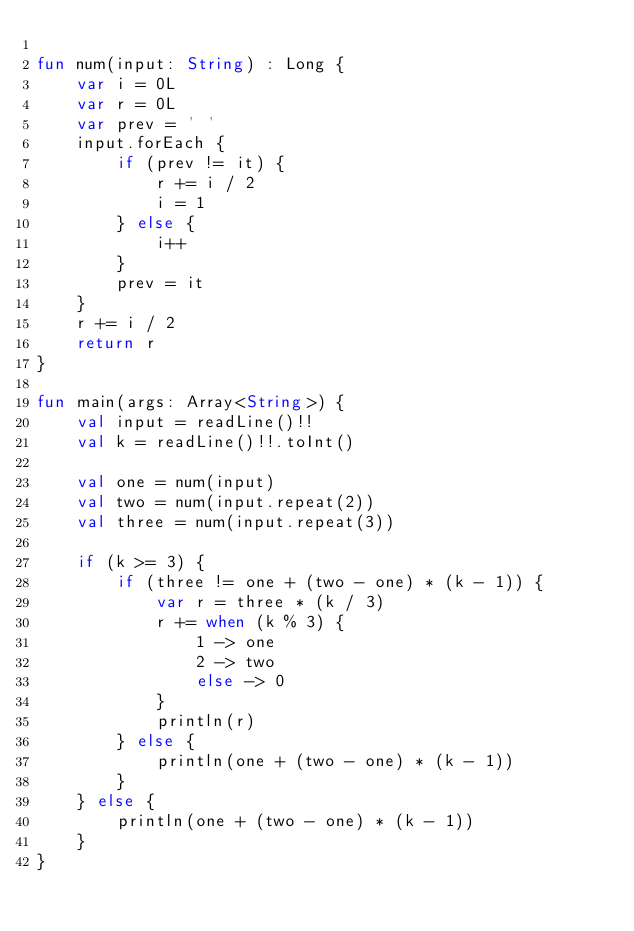<code> <loc_0><loc_0><loc_500><loc_500><_Kotlin_>
fun num(input: String) : Long {
    var i = 0L
    var r = 0L
    var prev = ' '
    input.forEach {
        if (prev != it) {
            r += i / 2
            i = 1
        } else {
            i++
        }
        prev = it
    }
    r += i / 2
    return r
}

fun main(args: Array<String>) {
    val input = readLine()!!
    val k = readLine()!!.toInt()

    val one = num(input)
    val two = num(input.repeat(2))
    val three = num(input.repeat(3))

    if (k >= 3) {
        if (three != one + (two - one) * (k - 1)) {
            var r = three * (k / 3)
            r += when (k % 3) {
                1 -> one
                2 -> two
                else -> 0
            }
            println(r)
        } else {
            println(one + (two - one) * (k - 1))
        }
    } else {
        println(one + (two - one) * (k - 1))
    }
}

</code> 